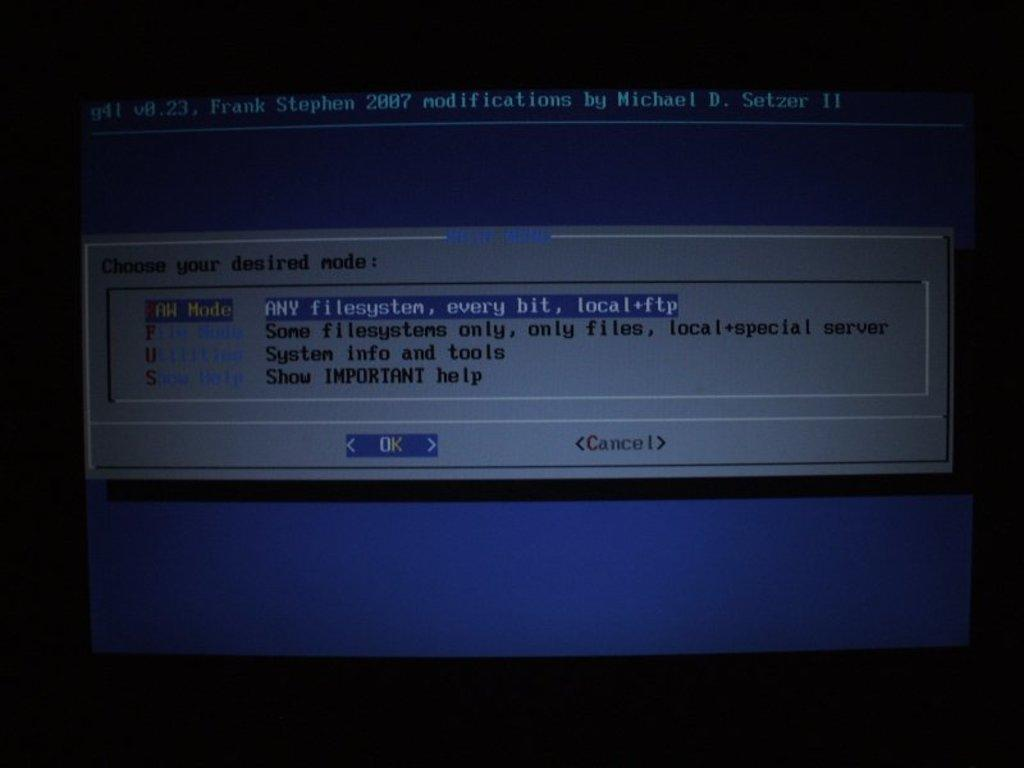<image>
Offer a succinct explanation of the picture presented. A computer screen wants the user to choose their desired mode. 